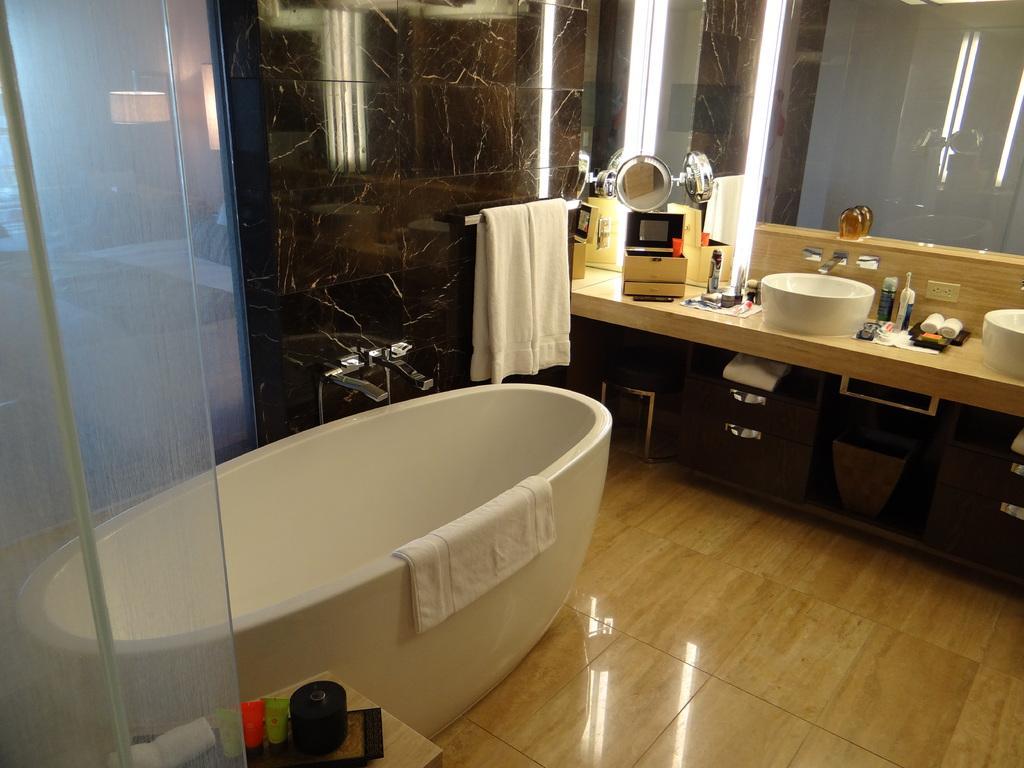Describe this image in one or two sentences. This image is taken in the bathroom and here we can see a bathtub, towels, sink and some objects on the table. In the background, there are marbles and we can see a mirror. At the bottom, there is a stand and there are some objects on it and there is a floor. 